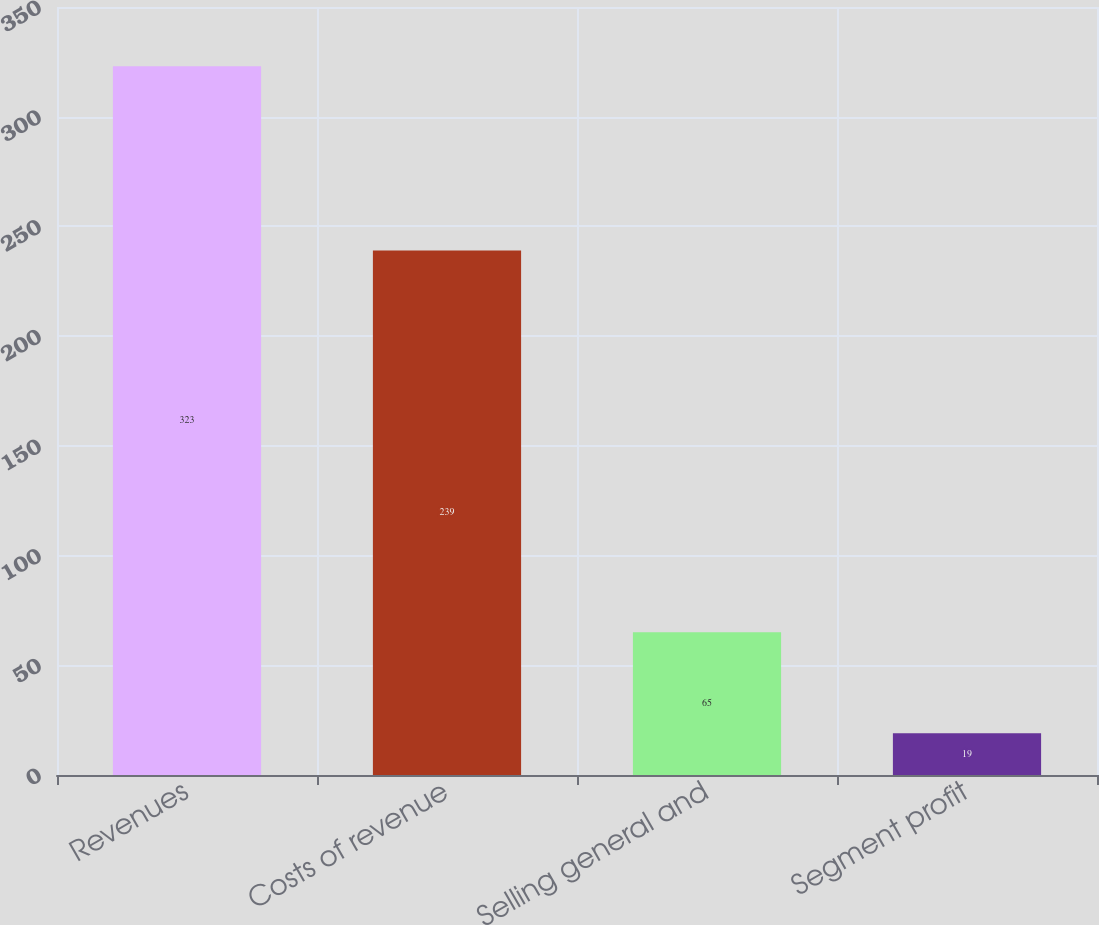Convert chart to OTSL. <chart><loc_0><loc_0><loc_500><loc_500><bar_chart><fcel>Revenues<fcel>Costs of revenue<fcel>Selling general and<fcel>Segment profit<nl><fcel>323<fcel>239<fcel>65<fcel>19<nl></chart> 